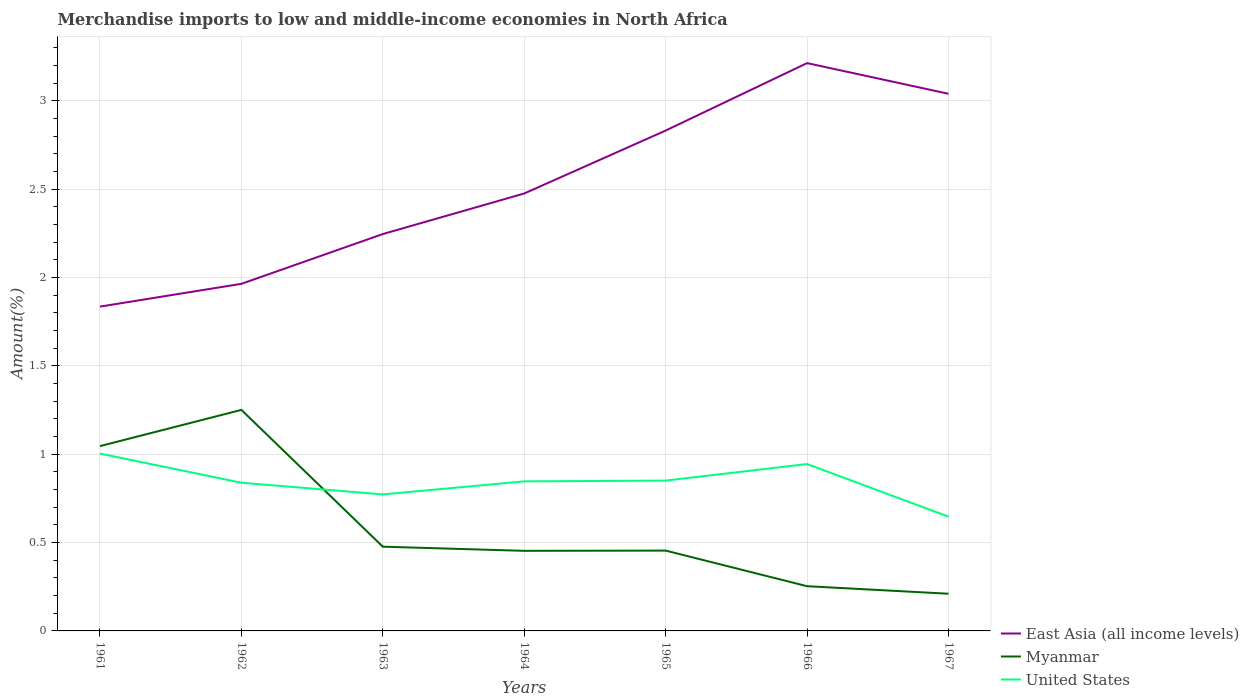How many different coloured lines are there?
Give a very brief answer. 3. Does the line corresponding to Myanmar intersect with the line corresponding to East Asia (all income levels)?
Make the answer very short. No. Across all years, what is the maximum percentage of amount earned from merchandise imports in Myanmar?
Offer a terse response. 0.21. In which year was the percentage of amount earned from merchandise imports in United States maximum?
Keep it short and to the point. 1967. What is the total percentage of amount earned from merchandise imports in United States in the graph?
Provide a short and direct response. -0.07. What is the difference between the highest and the second highest percentage of amount earned from merchandise imports in Myanmar?
Offer a terse response. 1.04. Is the percentage of amount earned from merchandise imports in United States strictly greater than the percentage of amount earned from merchandise imports in East Asia (all income levels) over the years?
Ensure brevity in your answer.  Yes. What is the difference between two consecutive major ticks on the Y-axis?
Keep it short and to the point. 0.5. Are the values on the major ticks of Y-axis written in scientific E-notation?
Ensure brevity in your answer.  No. Does the graph contain grids?
Offer a terse response. Yes. How are the legend labels stacked?
Your response must be concise. Vertical. What is the title of the graph?
Ensure brevity in your answer.  Merchandise imports to low and middle-income economies in North Africa. What is the label or title of the Y-axis?
Keep it short and to the point. Amount(%). What is the Amount(%) in East Asia (all income levels) in 1961?
Ensure brevity in your answer.  1.84. What is the Amount(%) in Myanmar in 1961?
Keep it short and to the point. 1.05. What is the Amount(%) of United States in 1961?
Provide a short and direct response. 1. What is the Amount(%) of East Asia (all income levels) in 1962?
Your response must be concise. 1.96. What is the Amount(%) in Myanmar in 1962?
Give a very brief answer. 1.25. What is the Amount(%) in United States in 1962?
Provide a succinct answer. 0.84. What is the Amount(%) of East Asia (all income levels) in 1963?
Provide a succinct answer. 2.25. What is the Amount(%) of Myanmar in 1963?
Provide a short and direct response. 0.48. What is the Amount(%) in United States in 1963?
Your answer should be very brief. 0.77. What is the Amount(%) in East Asia (all income levels) in 1964?
Keep it short and to the point. 2.48. What is the Amount(%) of Myanmar in 1964?
Your answer should be compact. 0.45. What is the Amount(%) in United States in 1964?
Give a very brief answer. 0.85. What is the Amount(%) in East Asia (all income levels) in 1965?
Offer a terse response. 2.83. What is the Amount(%) of Myanmar in 1965?
Provide a short and direct response. 0.45. What is the Amount(%) in United States in 1965?
Make the answer very short. 0.85. What is the Amount(%) of East Asia (all income levels) in 1966?
Make the answer very short. 3.21. What is the Amount(%) in Myanmar in 1966?
Give a very brief answer. 0.25. What is the Amount(%) in United States in 1966?
Provide a short and direct response. 0.94. What is the Amount(%) of East Asia (all income levels) in 1967?
Your response must be concise. 3.04. What is the Amount(%) of Myanmar in 1967?
Your response must be concise. 0.21. What is the Amount(%) in United States in 1967?
Your answer should be compact. 0.65. Across all years, what is the maximum Amount(%) of East Asia (all income levels)?
Your response must be concise. 3.21. Across all years, what is the maximum Amount(%) in Myanmar?
Your response must be concise. 1.25. Across all years, what is the maximum Amount(%) in United States?
Your response must be concise. 1. Across all years, what is the minimum Amount(%) in East Asia (all income levels)?
Give a very brief answer. 1.84. Across all years, what is the minimum Amount(%) of Myanmar?
Provide a succinct answer. 0.21. Across all years, what is the minimum Amount(%) in United States?
Keep it short and to the point. 0.65. What is the total Amount(%) of East Asia (all income levels) in the graph?
Your answer should be very brief. 17.61. What is the total Amount(%) in Myanmar in the graph?
Make the answer very short. 4.15. What is the total Amount(%) in United States in the graph?
Offer a terse response. 5.9. What is the difference between the Amount(%) in East Asia (all income levels) in 1961 and that in 1962?
Your answer should be compact. -0.13. What is the difference between the Amount(%) of Myanmar in 1961 and that in 1962?
Provide a succinct answer. -0.2. What is the difference between the Amount(%) in United States in 1961 and that in 1962?
Make the answer very short. 0.17. What is the difference between the Amount(%) in East Asia (all income levels) in 1961 and that in 1963?
Offer a terse response. -0.41. What is the difference between the Amount(%) of Myanmar in 1961 and that in 1963?
Your answer should be compact. 0.57. What is the difference between the Amount(%) of United States in 1961 and that in 1963?
Your response must be concise. 0.23. What is the difference between the Amount(%) in East Asia (all income levels) in 1961 and that in 1964?
Give a very brief answer. -0.64. What is the difference between the Amount(%) in Myanmar in 1961 and that in 1964?
Give a very brief answer. 0.59. What is the difference between the Amount(%) of United States in 1961 and that in 1964?
Provide a short and direct response. 0.16. What is the difference between the Amount(%) of East Asia (all income levels) in 1961 and that in 1965?
Keep it short and to the point. -1. What is the difference between the Amount(%) of Myanmar in 1961 and that in 1965?
Your response must be concise. 0.59. What is the difference between the Amount(%) in United States in 1961 and that in 1965?
Ensure brevity in your answer.  0.15. What is the difference between the Amount(%) of East Asia (all income levels) in 1961 and that in 1966?
Offer a terse response. -1.38. What is the difference between the Amount(%) of Myanmar in 1961 and that in 1966?
Provide a short and direct response. 0.79. What is the difference between the Amount(%) in United States in 1961 and that in 1966?
Your response must be concise. 0.06. What is the difference between the Amount(%) of East Asia (all income levels) in 1961 and that in 1967?
Make the answer very short. -1.2. What is the difference between the Amount(%) of Myanmar in 1961 and that in 1967?
Make the answer very short. 0.84. What is the difference between the Amount(%) in United States in 1961 and that in 1967?
Keep it short and to the point. 0.36. What is the difference between the Amount(%) of East Asia (all income levels) in 1962 and that in 1963?
Your answer should be compact. -0.28. What is the difference between the Amount(%) of Myanmar in 1962 and that in 1963?
Ensure brevity in your answer.  0.77. What is the difference between the Amount(%) of United States in 1962 and that in 1963?
Your answer should be very brief. 0.07. What is the difference between the Amount(%) of East Asia (all income levels) in 1962 and that in 1964?
Provide a short and direct response. -0.51. What is the difference between the Amount(%) in Myanmar in 1962 and that in 1964?
Your answer should be compact. 0.8. What is the difference between the Amount(%) of United States in 1962 and that in 1964?
Make the answer very short. -0.01. What is the difference between the Amount(%) of East Asia (all income levels) in 1962 and that in 1965?
Offer a very short reply. -0.87. What is the difference between the Amount(%) in Myanmar in 1962 and that in 1965?
Make the answer very short. 0.8. What is the difference between the Amount(%) in United States in 1962 and that in 1965?
Your answer should be compact. -0.01. What is the difference between the Amount(%) of East Asia (all income levels) in 1962 and that in 1966?
Give a very brief answer. -1.25. What is the difference between the Amount(%) in United States in 1962 and that in 1966?
Your answer should be compact. -0.11. What is the difference between the Amount(%) of East Asia (all income levels) in 1962 and that in 1967?
Keep it short and to the point. -1.08. What is the difference between the Amount(%) of Myanmar in 1962 and that in 1967?
Make the answer very short. 1.04. What is the difference between the Amount(%) in United States in 1962 and that in 1967?
Your answer should be compact. 0.19. What is the difference between the Amount(%) in East Asia (all income levels) in 1963 and that in 1964?
Offer a very short reply. -0.23. What is the difference between the Amount(%) of Myanmar in 1963 and that in 1964?
Make the answer very short. 0.02. What is the difference between the Amount(%) in United States in 1963 and that in 1964?
Provide a succinct answer. -0.07. What is the difference between the Amount(%) in East Asia (all income levels) in 1963 and that in 1965?
Provide a succinct answer. -0.59. What is the difference between the Amount(%) in Myanmar in 1963 and that in 1965?
Your answer should be compact. 0.02. What is the difference between the Amount(%) of United States in 1963 and that in 1965?
Provide a succinct answer. -0.08. What is the difference between the Amount(%) in East Asia (all income levels) in 1963 and that in 1966?
Provide a short and direct response. -0.97. What is the difference between the Amount(%) in Myanmar in 1963 and that in 1966?
Ensure brevity in your answer.  0.22. What is the difference between the Amount(%) of United States in 1963 and that in 1966?
Provide a succinct answer. -0.17. What is the difference between the Amount(%) of East Asia (all income levels) in 1963 and that in 1967?
Provide a short and direct response. -0.79. What is the difference between the Amount(%) in Myanmar in 1963 and that in 1967?
Offer a terse response. 0.27. What is the difference between the Amount(%) of United States in 1963 and that in 1967?
Make the answer very short. 0.13. What is the difference between the Amount(%) of East Asia (all income levels) in 1964 and that in 1965?
Offer a terse response. -0.36. What is the difference between the Amount(%) of Myanmar in 1964 and that in 1965?
Offer a terse response. -0. What is the difference between the Amount(%) of United States in 1964 and that in 1965?
Give a very brief answer. -0. What is the difference between the Amount(%) of East Asia (all income levels) in 1964 and that in 1966?
Keep it short and to the point. -0.74. What is the difference between the Amount(%) of Myanmar in 1964 and that in 1966?
Keep it short and to the point. 0.2. What is the difference between the Amount(%) of United States in 1964 and that in 1966?
Ensure brevity in your answer.  -0.1. What is the difference between the Amount(%) in East Asia (all income levels) in 1964 and that in 1967?
Keep it short and to the point. -0.56. What is the difference between the Amount(%) of Myanmar in 1964 and that in 1967?
Provide a succinct answer. 0.24. What is the difference between the Amount(%) of United States in 1964 and that in 1967?
Offer a terse response. 0.2. What is the difference between the Amount(%) in East Asia (all income levels) in 1965 and that in 1966?
Offer a terse response. -0.38. What is the difference between the Amount(%) in Myanmar in 1965 and that in 1966?
Keep it short and to the point. 0.2. What is the difference between the Amount(%) of United States in 1965 and that in 1966?
Give a very brief answer. -0.09. What is the difference between the Amount(%) of East Asia (all income levels) in 1965 and that in 1967?
Your answer should be very brief. -0.21. What is the difference between the Amount(%) in Myanmar in 1965 and that in 1967?
Your answer should be very brief. 0.24. What is the difference between the Amount(%) in United States in 1965 and that in 1967?
Ensure brevity in your answer.  0.2. What is the difference between the Amount(%) of East Asia (all income levels) in 1966 and that in 1967?
Offer a terse response. 0.17. What is the difference between the Amount(%) of Myanmar in 1966 and that in 1967?
Give a very brief answer. 0.04. What is the difference between the Amount(%) of United States in 1966 and that in 1967?
Ensure brevity in your answer.  0.3. What is the difference between the Amount(%) of East Asia (all income levels) in 1961 and the Amount(%) of Myanmar in 1962?
Ensure brevity in your answer.  0.58. What is the difference between the Amount(%) in East Asia (all income levels) in 1961 and the Amount(%) in United States in 1962?
Provide a short and direct response. 1. What is the difference between the Amount(%) in Myanmar in 1961 and the Amount(%) in United States in 1962?
Provide a short and direct response. 0.21. What is the difference between the Amount(%) in East Asia (all income levels) in 1961 and the Amount(%) in Myanmar in 1963?
Make the answer very short. 1.36. What is the difference between the Amount(%) in East Asia (all income levels) in 1961 and the Amount(%) in United States in 1963?
Make the answer very short. 1.06. What is the difference between the Amount(%) of Myanmar in 1961 and the Amount(%) of United States in 1963?
Offer a very short reply. 0.27. What is the difference between the Amount(%) in East Asia (all income levels) in 1961 and the Amount(%) in Myanmar in 1964?
Ensure brevity in your answer.  1.38. What is the difference between the Amount(%) in East Asia (all income levels) in 1961 and the Amount(%) in United States in 1964?
Offer a terse response. 0.99. What is the difference between the Amount(%) in Myanmar in 1961 and the Amount(%) in United States in 1964?
Offer a terse response. 0.2. What is the difference between the Amount(%) in East Asia (all income levels) in 1961 and the Amount(%) in Myanmar in 1965?
Your answer should be very brief. 1.38. What is the difference between the Amount(%) of East Asia (all income levels) in 1961 and the Amount(%) of United States in 1965?
Offer a very short reply. 0.98. What is the difference between the Amount(%) in Myanmar in 1961 and the Amount(%) in United States in 1965?
Provide a short and direct response. 0.2. What is the difference between the Amount(%) of East Asia (all income levels) in 1961 and the Amount(%) of Myanmar in 1966?
Your answer should be compact. 1.58. What is the difference between the Amount(%) in East Asia (all income levels) in 1961 and the Amount(%) in United States in 1966?
Make the answer very short. 0.89. What is the difference between the Amount(%) of Myanmar in 1961 and the Amount(%) of United States in 1966?
Offer a terse response. 0.1. What is the difference between the Amount(%) in East Asia (all income levels) in 1961 and the Amount(%) in Myanmar in 1967?
Make the answer very short. 1.63. What is the difference between the Amount(%) of East Asia (all income levels) in 1961 and the Amount(%) of United States in 1967?
Keep it short and to the point. 1.19. What is the difference between the Amount(%) in Myanmar in 1961 and the Amount(%) in United States in 1967?
Ensure brevity in your answer.  0.4. What is the difference between the Amount(%) in East Asia (all income levels) in 1962 and the Amount(%) in Myanmar in 1963?
Offer a terse response. 1.49. What is the difference between the Amount(%) in East Asia (all income levels) in 1962 and the Amount(%) in United States in 1963?
Provide a short and direct response. 1.19. What is the difference between the Amount(%) of Myanmar in 1962 and the Amount(%) of United States in 1963?
Keep it short and to the point. 0.48. What is the difference between the Amount(%) in East Asia (all income levels) in 1962 and the Amount(%) in Myanmar in 1964?
Give a very brief answer. 1.51. What is the difference between the Amount(%) of East Asia (all income levels) in 1962 and the Amount(%) of United States in 1964?
Your answer should be very brief. 1.12. What is the difference between the Amount(%) of Myanmar in 1962 and the Amount(%) of United States in 1964?
Give a very brief answer. 0.4. What is the difference between the Amount(%) in East Asia (all income levels) in 1962 and the Amount(%) in Myanmar in 1965?
Your answer should be compact. 1.51. What is the difference between the Amount(%) in East Asia (all income levels) in 1962 and the Amount(%) in United States in 1965?
Provide a succinct answer. 1.11. What is the difference between the Amount(%) in Myanmar in 1962 and the Amount(%) in United States in 1965?
Give a very brief answer. 0.4. What is the difference between the Amount(%) in East Asia (all income levels) in 1962 and the Amount(%) in Myanmar in 1966?
Provide a succinct answer. 1.71. What is the difference between the Amount(%) of East Asia (all income levels) in 1962 and the Amount(%) of United States in 1966?
Keep it short and to the point. 1.02. What is the difference between the Amount(%) of Myanmar in 1962 and the Amount(%) of United States in 1966?
Offer a terse response. 0.31. What is the difference between the Amount(%) of East Asia (all income levels) in 1962 and the Amount(%) of Myanmar in 1967?
Offer a terse response. 1.75. What is the difference between the Amount(%) of East Asia (all income levels) in 1962 and the Amount(%) of United States in 1967?
Provide a short and direct response. 1.32. What is the difference between the Amount(%) of Myanmar in 1962 and the Amount(%) of United States in 1967?
Offer a terse response. 0.6. What is the difference between the Amount(%) in East Asia (all income levels) in 1963 and the Amount(%) in Myanmar in 1964?
Ensure brevity in your answer.  1.79. What is the difference between the Amount(%) in Myanmar in 1963 and the Amount(%) in United States in 1964?
Your answer should be very brief. -0.37. What is the difference between the Amount(%) in East Asia (all income levels) in 1963 and the Amount(%) in Myanmar in 1965?
Your answer should be compact. 1.79. What is the difference between the Amount(%) of East Asia (all income levels) in 1963 and the Amount(%) of United States in 1965?
Keep it short and to the point. 1.4. What is the difference between the Amount(%) of Myanmar in 1963 and the Amount(%) of United States in 1965?
Your answer should be very brief. -0.37. What is the difference between the Amount(%) in East Asia (all income levels) in 1963 and the Amount(%) in Myanmar in 1966?
Keep it short and to the point. 1.99. What is the difference between the Amount(%) of East Asia (all income levels) in 1963 and the Amount(%) of United States in 1966?
Offer a very short reply. 1.3. What is the difference between the Amount(%) of Myanmar in 1963 and the Amount(%) of United States in 1966?
Offer a terse response. -0.47. What is the difference between the Amount(%) of East Asia (all income levels) in 1963 and the Amount(%) of Myanmar in 1967?
Keep it short and to the point. 2.04. What is the difference between the Amount(%) of East Asia (all income levels) in 1963 and the Amount(%) of United States in 1967?
Provide a succinct answer. 1.6. What is the difference between the Amount(%) in Myanmar in 1963 and the Amount(%) in United States in 1967?
Keep it short and to the point. -0.17. What is the difference between the Amount(%) of East Asia (all income levels) in 1964 and the Amount(%) of Myanmar in 1965?
Ensure brevity in your answer.  2.02. What is the difference between the Amount(%) of East Asia (all income levels) in 1964 and the Amount(%) of United States in 1965?
Your answer should be very brief. 1.63. What is the difference between the Amount(%) of Myanmar in 1964 and the Amount(%) of United States in 1965?
Provide a short and direct response. -0.4. What is the difference between the Amount(%) of East Asia (all income levels) in 1964 and the Amount(%) of Myanmar in 1966?
Your response must be concise. 2.22. What is the difference between the Amount(%) of East Asia (all income levels) in 1964 and the Amount(%) of United States in 1966?
Keep it short and to the point. 1.53. What is the difference between the Amount(%) in Myanmar in 1964 and the Amount(%) in United States in 1966?
Provide a short and direct response. -0.49. What is the difference between the Amount(%) of East Asia (all income levels) in 1964 and the Amount(%) of Myanmar in 1967?
Provide a short and direct response. 2.27. What is the difference between the Amount(%) of East Asia (all income levels) in 1964 and the Amount(%) of United States in 1967?
Provide a short and direct response. 1.83. What is the difference between the Amount(%) of Myanmar in 1964 and the Amount(%) of United States in 1967?
Your answer should be very brief. -0.19. What is the difference between the Amount(%) in East Asia (all income levels) in 1965 and the Amount(%) in Myanmar in 1966?
Provide a short and direct response. 2.58. What is the difference between the Amount(%) of East Asia (all income levels) in 1965 and the Amount(%) of United States in 1966?
Keep it short and to the point. 1.89. What is the difference between the Amount(%) of Myanmar in 1965 and the Amount(%) of United States in 1966?
Ensure brevity in your answer.  -0.49. What is the difference between the Amount(%) of East Asia (all income levels) in 1965 and the Amount(%) of Myanmar in 1967?
Provide a succinct answer. 2.62. What is the difference between the Amount(%) of East Asia (all income levels) in 1965 and the Amount(%) of United States in 1967?
Keep it short and to the point. 2.19. What is the difference between the Amount(%) in Myanmar in 1965 and the Amount(%) in United States in 1967?
Keep it short and to the point. -0.19. What is the difference between the Amount(%) in East Asia (all income levels) in 1966 and the Amount(%) in Myanmar in 1967?
Offer a very short reply. 3. What is the difference between the Amount(%) of East Asia (all income levels) in 1966 and the Amount(%) of United States in 1967?
Keep it short and to the point. 2.57. What is the difference between the Amount(%) in Myanmar in 1966 and the Amount(%) in United States in 1967?
Make the answer very short. -0.39. What is the average Amount(%) of East Asia (all income levels) per year?
Your response must be concise. 2.52. What is the average Amount(%) in Myanmar per year?
Offer a very short reply. 0.59. What is the average Amount(%) of United States per year?
Offer a very short reply. 0.84. In the year 1961, what is the difference between the Amount(%) of East Asia (all income levels) and Amount(%) of Myanmar?
Give a very brief answer. 0.79. In the year 1961, what is the difference between the Amount(%) in East Asia (all income levels) and Amount(%) in United States?
Give a very brief answer. 0.83. In the year 1961, what is the difference between the Amount(%) in Myanmar and Amount(%) in United States?
Make the answer very short. 0.04. In the year 1962, what is the difference between the Amount(%) of East Asia (all income levels) and Amount(%) of Myanmar?
Your response must be concise. 0.71. In the year 1962, what is the difference between the Amount(%) in East Asia (all income levels) and Amount(%) in United States?
Make the answer very short. 1.13. In the year 1962, what is the difference between the Amount(%) in Myanmar and Amount(%) in United States?
Your response must be concise. 0.41. In the year 1963, what is the difference between the Amount(%) in East Asia (all income levels) and Amount(%) in Myanmar?
Offer a terse response. 1.77. In the year 1963, what is the difference between the Amount(%) in East Asia (all income levels) and Amount(%) in United States?
Keep it short and to the point. 1.47. In the year 1963, what is the difference between the Amount(%) of Myanmar and Amount(%) of United States?
Offer a terse response. -0.3. In the year 1964, what is the difference between the Amount(%) of East Asia (all income levels) and Amount(%) of Myanmar?
Your answer should be very brief. 2.02. In the year 1964, what is the difference between the Amount(%) of East Asia (all income levels) and Amount(%) of United States?
Provide a short and direct response. 1.63. In the year 1964, what is the difference between the Amount(%) in Myanmar and Amount(%) in United States?
Give a very brief answer. -0.39. In the year 1965, what is the difference between the Amount(%) of East Asia (all income levels) and Amount(%) of Myanmar?
Give a very brief answer. 2.38. In the year 1965, what is the difference between the Amount(%) of East Asia (all income levels) and Amount(%) of United States?
Your response must be concise. 1.98. In the year 1965, what is the difference between the Amount(%) in Myanmar and Amount(%) in United States?
Your answer should be very brief. -0.4. In the year 1966, what is the difference between the Amount(%) of East Asia (all income levels) and Amount(%) of Myanmar?
Keep it short and to the point. 2.96. In the year 1966, what is the difference between the Amount(%) in East Asia (all income levels) and Amount(%) in United States?
Offer a terse response. 2.27. In the year 1966, what is the difference between the Amount(%) of Myanmar and Amount(%) of United States?
Offer a terse response. -0.69. In the year 1967, what is the difference between the Amount(%) in East Asia (all income levels) and Amount(%) in Myanmar?
Keep it short and to the point. 2.83. In the year 1967, what is the difference between the Amount(%) in East Asia (all income levels) and Amount(%) in United States?
Give a very brief answer. 2.39. In the year 1967, what is the difference between the Amount(%) in Myanmar and Amount(%) in United States?
Offer a terse response. -0.44. What is the ratio of the Amount(%) in East Asia (all income levels) in 1961 to that in 1962?
Your answer should be compact. 0.93. What is the ratio of the Amount(%) of Myanmar in 1961 to that in 1962?
Offer a terse response. 0.84. What is the ratio of the Amount(%) in United States in 1961 to that in 1962?
Your answer should be compact. 1.2. What is the ratio of the Amount(%) in East Asia (all income levels) in 1961 to that in 1963?
Offer a very short reply. 0.82. What is the ratio of the Amount(%) of Myanmar in 1961 to that in 1963?
Provide a succinct answer. 2.19. What is the ratio of the Amount(%) of United States in 1961 to that in 1963?
Give a very brief answer. 1.3. What is the ratio of the Amount(%) in East Asia (all income levels) in 1961 to that in 1964?
Give a very brief answer. 0.74. What is the ratio of the Amount(%) in Myanmar in 1961 to that in 1964?
Provide a succinct answer. 2.31. What is the ratio of the Amount(%) of United States in 1961 to that in 1964?
Offer a very short reply. 1.19. What is the ratio of the Amount(%) in East Asia (all income levels) in 1961 to that in 1965?
Your answer should be compact. 0.65. What is the ratio of the Amount(%) of Myanmar in 1961 to that in 1965?
Give a very brief answer. 2.3. What is the ratio of the Amount(%) in United States in 1961 to that in 1965?
Your answer should be very brief. 1.18. What is the ratio of the Amount(%) of East Asia (all income levels) in 1961 to that in 1966?
Keep it short and to the point. 0.57. What is the ratio of the Amount(%) of Myanmar in 1961 to that in 1966?
Offer a terse response. 4.13. What is the ratio of the Amount(%) in United States in 1961 to that in 1966?
Provide a succinct answer. 1.06. What is the ratio of the Amount(%) of East Asia (all income levels) in 1961 to that in 1967?
Provide a succinct answer. 0.6. What is the ratio of the Amount(%) in Myanmar in 1961 to that in 1967?
Your answer should be compact. 4.97. What is the ratio of the Amount(%) in United States in 1961 to that in 1967?
Your answer should be very brief. 1.55. What is the ratio of the Amount(%) in East Asia (all income levels) in 1962 to that in 1963?
Ensure brevity in your answer.  0.87. What is the ratio of the Amount(%) of Myanmar in 1962 to that in 1963?
Provide a short and direct response. 2.62. What is the ratio of the Amount(%) of United States in 1962 to that in 1963?
Your answer should be compact. 1.09. What is the ratio of the Amount(%) of East Asia (all income levels) in 1962 to that in 1964?
Make the answer very short. 0.79. What is the ratio of the Amount(%) of Myanmar in 1962 to that in 1964?
Your answer should be compact. 2.76. What is the ratio of the Amount(%) in United States in 1962 to that in 1964?
Your answer should be very brief. 0.99. What is the ratio of the Amount(%) in East Asia (all income levels) in 1962 to that in 1965?
Your answer should be very brief. 0.69. What is the ratio of the Amount(%) of Myanmar in 1962 to that in 1965?
Give a very brief answer. 2.75. What is the ratio of the Amount(%) of United States in 1962 to that in 1965?
Provide a short and direct response. 0.99. What is the ratio of the Amount(%) of East Asia (all income levels) in 1962 to that in 1966?
Give a very brief answer. 0.61. What is the ratio of the Amount(%) of Myanmar in 1962 to that in 1966?
Provide a short and direct response. 4.94. What is the ratio of the Amount(%) in United States in 1962 to that in 1966?
Provide a short and direct response. 0.89. What is the ratio of the Amount(%) in East Asia (all income levels) in 1962 to that in 1967?
Your answer should be very brief. 0.65. What is the ratio of the Amount(%) in Myanmar in 1962 to that in 1967?
Offer a terse response. 5.94. What is the ratio of the Amount(%) in United States in 1962 to that in 1967?
Offer a terse response. 1.3. What is the ratio of the Amount(%) of East Asia (all income levels) in 1963 to that in 1964?
Offer a very short reply. 0.91. What is the ratio of the Amount(%) in Myanmar in 1963 to that in 1964?
Ensure brevity in your answer.  1.05. What is the ratio of the Amount(%) of United States in 1963 to that in 1964?
Offer a very short reply. 0.91. What is the ratio of the Amount(%) in East Asia (all income levels) in 1963 to that in 1965?
Offer a very short reply. 0.79. What is the ratio of the Amount(%) of Myanmar in 1963 to that in 1965?
Offer a very short reply. 1.05. What is the ratio of the Amount(%) of United States in 1963 to that in 1965?
Offer a very short reply. 0.91. What is the ratio of the Amount(%) in East Asia (all income levels) in 1963 to that in 1966?
Make the answer very short. 0.7. What is the ratio of the Amount(%) of Myanmar in 1963 to that in 1966?
Provide a succinct answer. 1.88. What is the ratio of the Amount(%) of United States in 1963 to that in 1966?
Your response must be concise. 0.82. What is the ratio of the Amount(%) in East Asia (all income levels) in 1963 to that in 1967?
Offer a terse response. 0.74. What is the ratio of the Amount(%) in Myanmar in 1963 to that in 1967?
Give a very brief answer. 2.26. What is the ratio of the Amount(%) of United States in 1963 to that in 1967?
Keep it short and to the point. 1.19. What is the ratio of the Amount(%) in East Asia (all income levels) in 1964 to that in 1965?
Your answer should be compact. 0.87. What is the ratio of the Amount(%) of Myanmar in 1964 to that in 1965?
Offer a terse response. 1. What is the ratio of the Amount(%) in East Asia (all income levels) in 1964 to that in 1966?
Offer a terse response. 0.77. What is the ratio of the Amount(%) of Myanmar in 1964 to that in 1966?
Give a very brief answer. 1.79. What is the ratio of the Amount(%) of United States in 1964 to that in 1966?
Offer a terse response. 0.9. What is the ratio of the Amount(%) in East Asia (all income levels) in 1964 to that in 1967?
Your response must be concise. 0.81. What is the ratio of the Amount(%) in Myanmar in 1964 to that in 1967?
Your response must be concise. 2.15. What is the ratio of the Amount(%) in United States in 1964 to that in 1967?
Give a very brief answer. 1.31. What is the ratio of the Amount(%) of East Asia (all income levels) in 1965 to that in 1966?
Your answer should be compact. 0.88. What is the ratio of the Amount(%) of Myanmar in 1965 to that in 1966?
Offer a terse response. 1.8. What is the ratio of the Amount(%) of United States in 1965 to that in 1966?
Ensure brevity in your answer.  0.9. What is the ratio of the Amount(%) of East Asia (all income levels) in 1965 to that in 1967?
Your answer should be compact. 0.93. What is the ratio of the Amount(%) in Myanmar in 1965 to that in 1967?
Your answer should be compact. 2.16. What is the ratio of the Amount(%) in United States in 1965 to that in 1967?
Keep it short and to the point. 1.32. What is the ratio of the Amount(%) in East Asia (all income levels) in 1966 to that in 1967?
Offer a very short reply. 1.06. What is the ratio of the Amount(%) in Myanmar in 1966 to that in 1967?
Provide a short and direct response. 1.2. What is the ratio of the Amount(%) of United States in 1966 to that in 1967?
Your answer should be very brief. 1.46. What is the difference between the highest and the second highest Amount(%) of East Asia (all income levels)?
Make the answer very short. 0.17. What is the difference between the highest and the second highest Amount(%) in Myanmar?
Ensure brevity in your answer.  0.2. What is the difference between the highest and the second highest Amount(%) in United States?
Give a very brief answer. 0.06. What is the difference between the highest and the lowest Amount(%) in East Asia (all income levels)?
Offer a very short reply. 1.38. What is the difference between the highest and the lowest Amount(%) in Myanmar?
Your answer should be very brief. 1.04. What is the difference between the highest and the lowest Amount(%) of United States?
Ensure brevity in your answer.  0.36. 